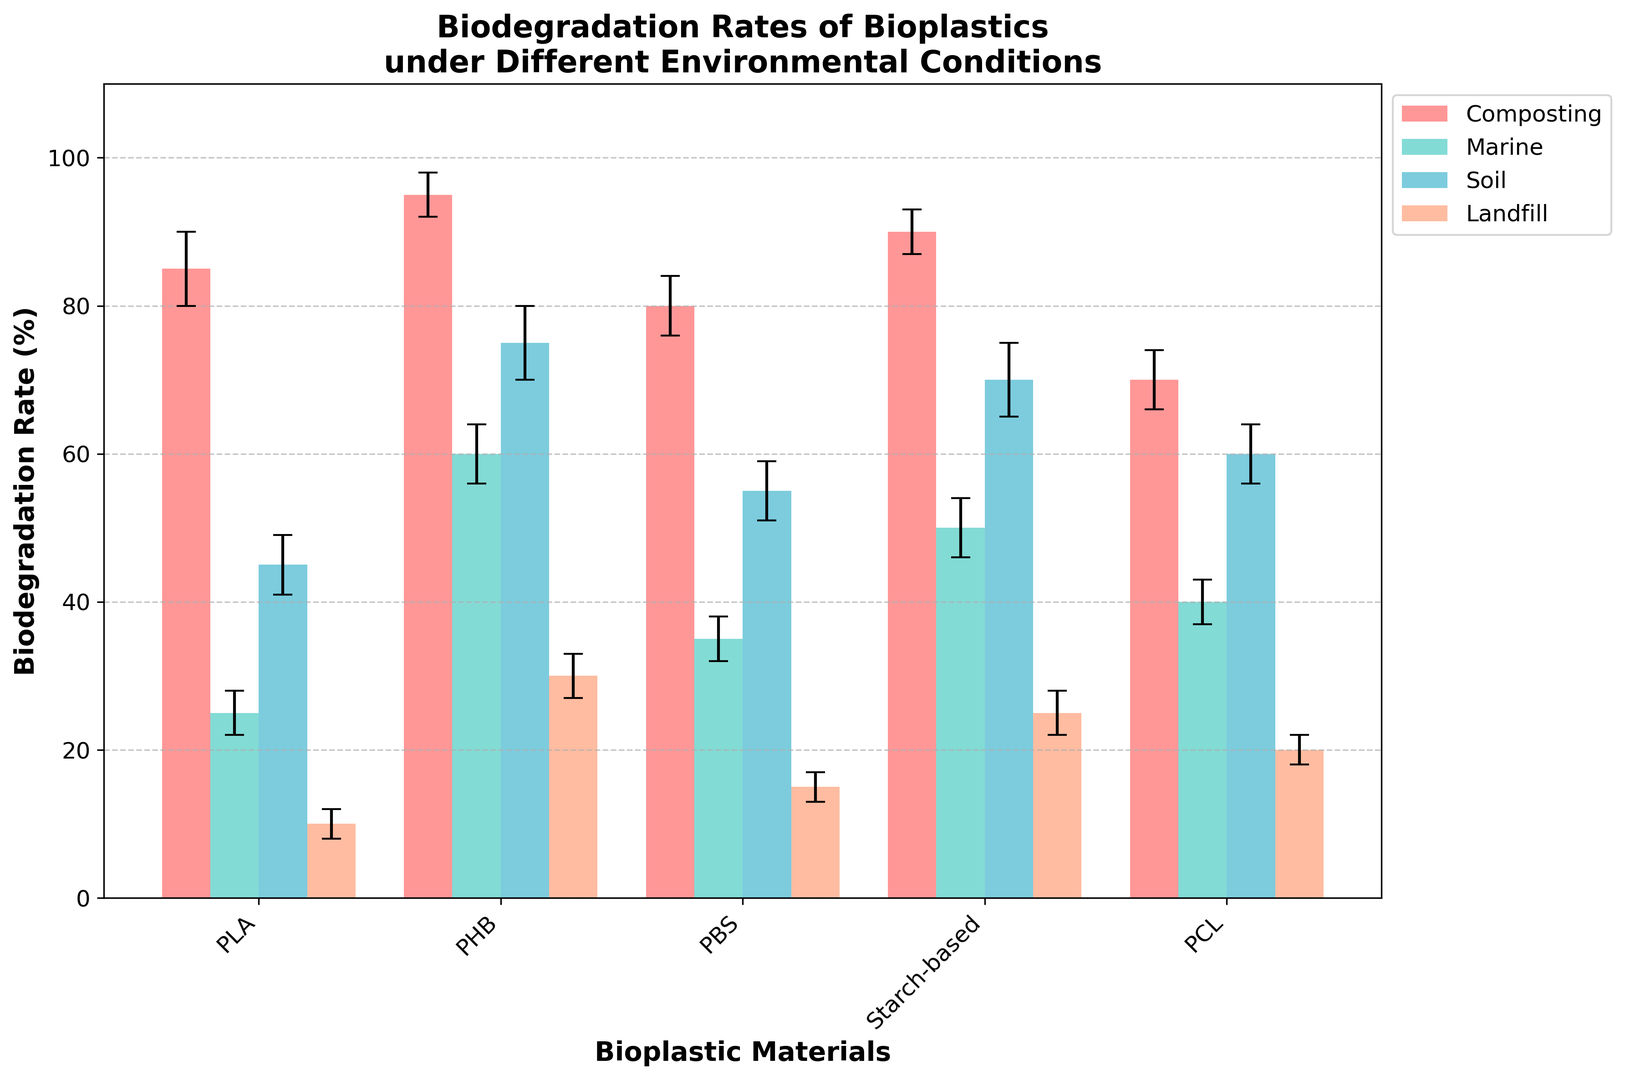Which bioplastic material has the highest biodegradation rate under composting conditions? The bar heights represent biodegradation rates. Under composting conditions, PHB has the highest bar, indicating the highest rate.
Answer: PHB What's the difference in biodegradation rates between PLAs under soil and marine conditions? PLA has a biodegradation rate of 45% under soil and 25% under marine. The difference is 45 - 25.
Answer: 20% Which material has the lowest biodegradation rate under marine conditions, and what is that rate? The heights of the bars under marine conditions vary. PLA has the shortest bar, representing the lowest rate.
Answer: PLA, 25% Between PHB and PBS, which has a greater average biodegradation rate across all conditions? Calculate the average biodegradation rate for both materials across four conditions: PHB (95+60+75+30)/4 = 65% and PBS (80+35+55+15)/4 = 46%.
Answer: PHB Which bioplastic shows the most significant difference in biodegradation rate between composting and landfill conditions? Compare the differences for each material between composting and landfill: 
PLA: 85 - 10 = 75%
PHB: 95 - 30 = 65%
PBS: 80 - 15 = 65%
Starch-based: 90 - 25 = 65%
PCL: 70 - 20 = 50%
PLA has the most significant difference.
Answer: PLA, 75% What is the average error margin for biodegradation rates of Starch-based materials across all conditions? The errors for Starch-based materials are: 3, 4, 5, 3. Calculate the average: (3+4+5+3)/4 = 3.75.
Answer: 3.75 Are there any materials with the same biodegradation rate under landfill conditions? If so, name them. Under landfill conditions: PLA = 10%, PHB = 30%, PBS = 15%, Starch-based = 25%, PCL = 20%. No rates are the same.
Answer: No Which condition generally shows the highest biodegradation rates and how do you know? Look at bar heights for each condition across all materials. Composting condition generally has the highest bars for all materials.
Answer: Composting What is the total biodegradation rate of PCL across all conditions? Sum the biodegradation rates of PCL: 70 + 40 + 60 + 20 = 190.
Answer: 190% Which material has a higher biodegradation rate in soil conditions compared to the average rate across all materials and conditions combined? Calculate average rate across all: (85+25+45+10+95+60+75+30+80+35+55+15+90+50+70+25+70+40+60+20)/20 = 49%. Compare individual soil rates: 
PLA = 45%
PHB = 75%
PBS = 55%
Starch-based = 70%
PCL = 60%
Materials above 49% in soil are PHB, PBS, Starch-based, and PCL.
Answer: PHB, PBS, Starch-based, PCL 